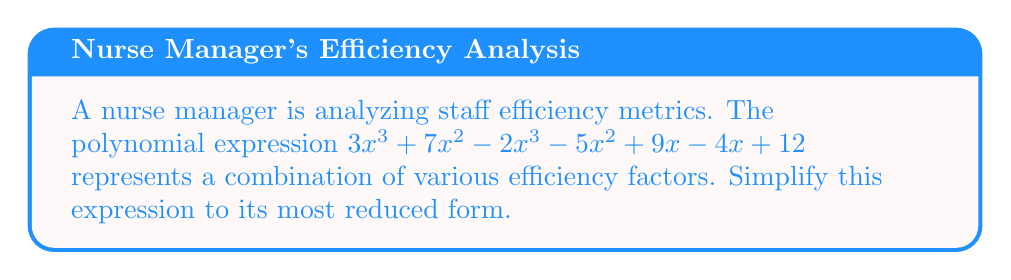What is the answer to this math problem? Let's simplify the polynomial expression step by step:

1) First, we'll group like terms:
   $$(3x^3 - 2x^3) + (7x^2 - 5x^2) + (9x - 4x) + 12$$

2) Now, let's simplify each group:
   
   For $x^3$ terms: $3x^3 - 2x^3 = x^3$
   
   For $x^2$ terms: $7x^2 - 5x^2 = 2x^2$
   
   For $x$ terms: $9x - 4x = 5x$
   
   The constant term remains 12

3) Rewriting our simplified expression:
   $$x^3 + 2x^2 + 5x + 12$$

4) This polynomial is already in its simplest form as there are no like terms left to combine.
Answer: $x^3 + 2x^2 + 5x + 12$ 